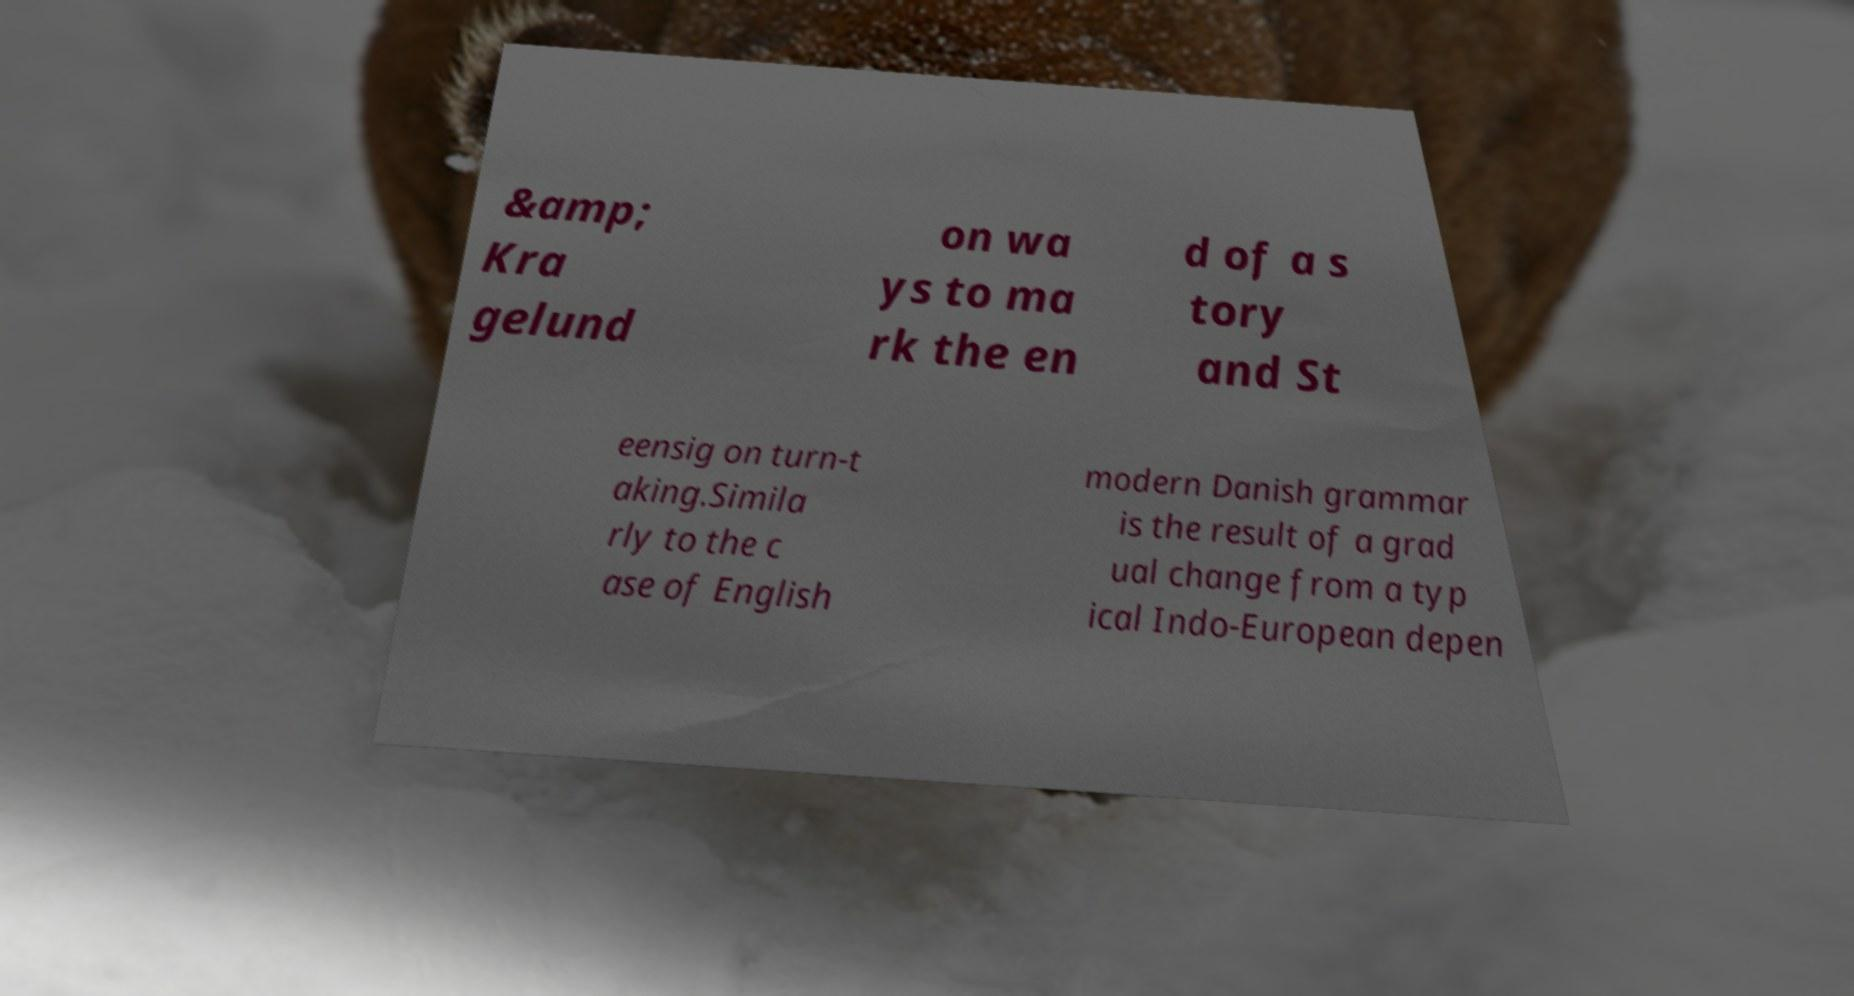Could you assist in decoding the text presented in this image and type it out clearly? &amp; Kra gelund on wa ys to ma rk the en d of a s tory and St eensig on turn-t aking.Simila rly to the c ase of English modern Danish grammar is the result of a grad ual change from a typ ical Indo-European depen 